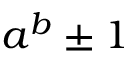<formula> <loc_0><loc_0><loc_500><loc_500>a ^ { b } \pm 1</formula> 